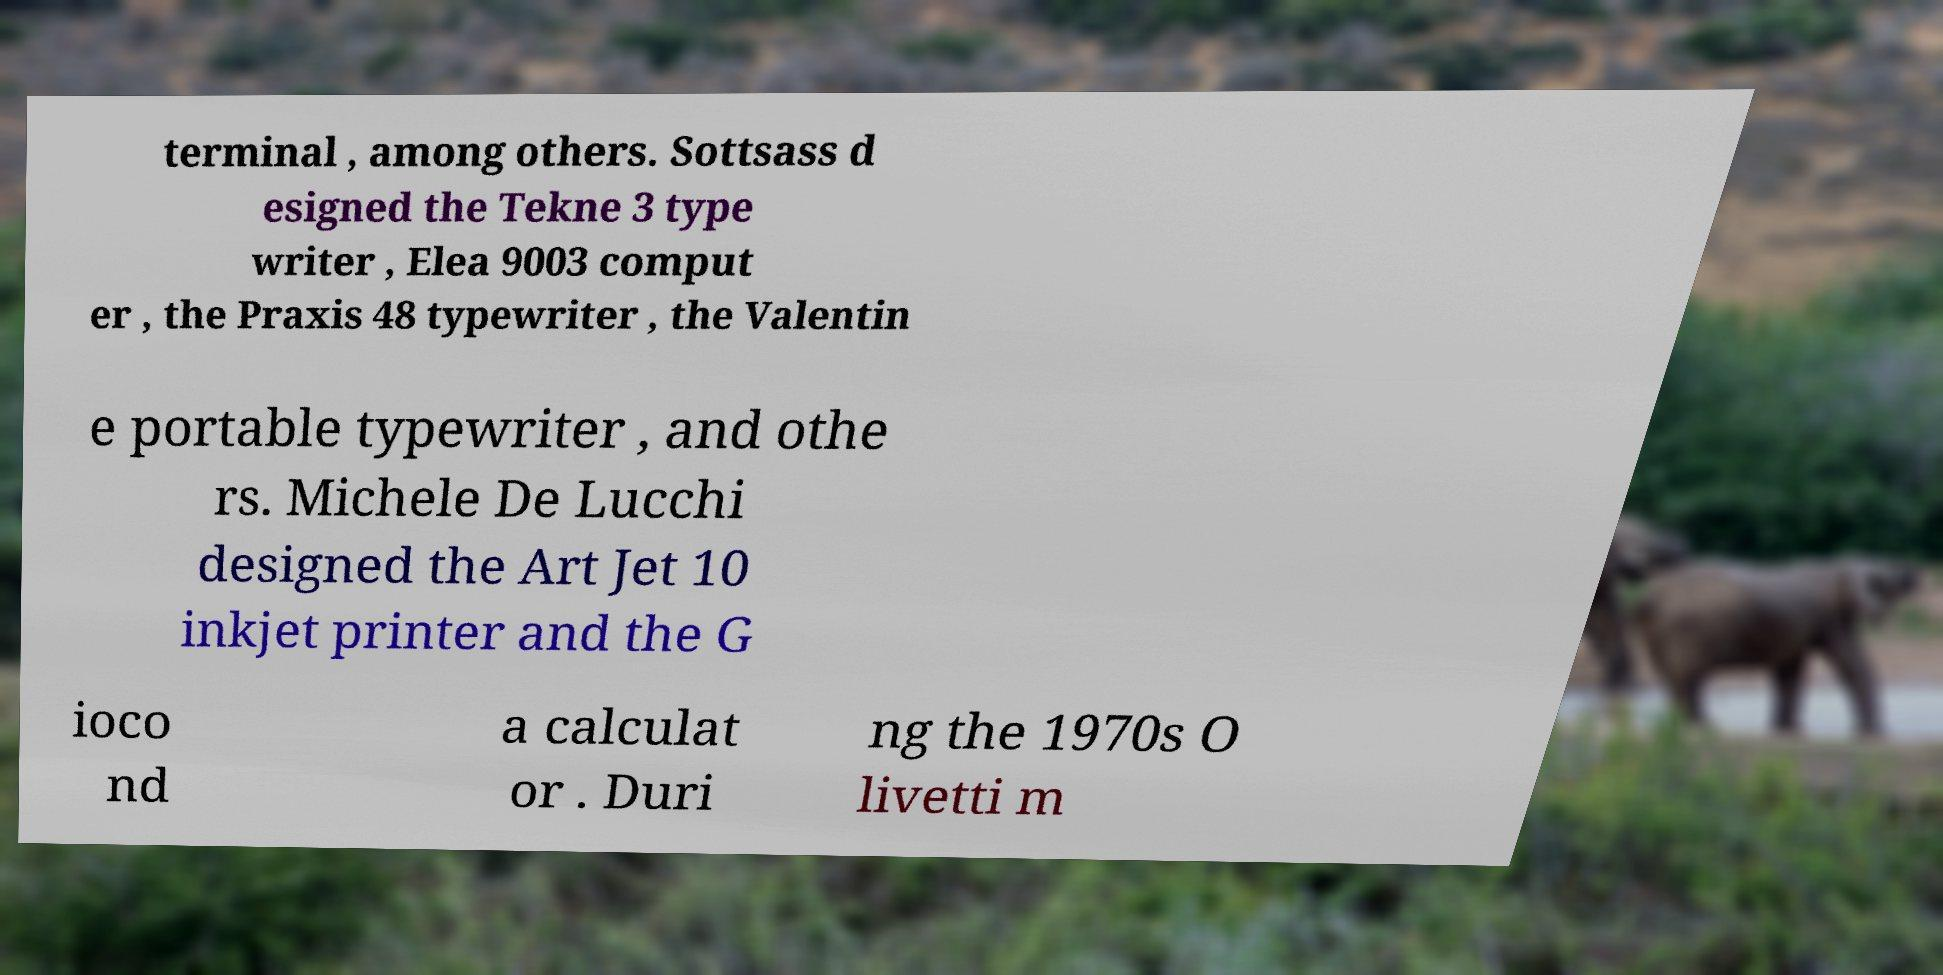Can you read and provide the text displayed in the image?This photo seems to have some interesting text. Can you extract and type it out for me? terminal , among others. Sottsass d esigned the Tekne 3 type writer , Elea 9003 comput er , the Praxis 48 typewriter , the Valentin e portable typewriter , and othe rs. Michele De Lucchi designed the Art Jet 10 inkjet printer and the G ioco nd a calculat or . Duri ng the 1970s O livetti m 